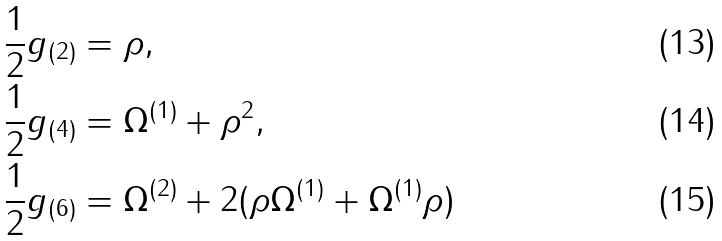<formula> <loc_0><loc_0><loc_500><loc_500>\frac { 1 } { 2 } g _ { ( 2 ) } & = \rho , \\ \frac { 1 } { 2 } g _ { ( 4 ) } & = \Omega ^ { ( 1 ) } + \rho ^ { 2 } , \\ \frac { 1 } { 2 } g _ { ( 6 ) } & = \Omega ^ { ( 2 ) } + 2 ( \rho \Omega ^ { ( 1 ) } + \Omega ^ { ( 1 ) } \rho )</formula> 